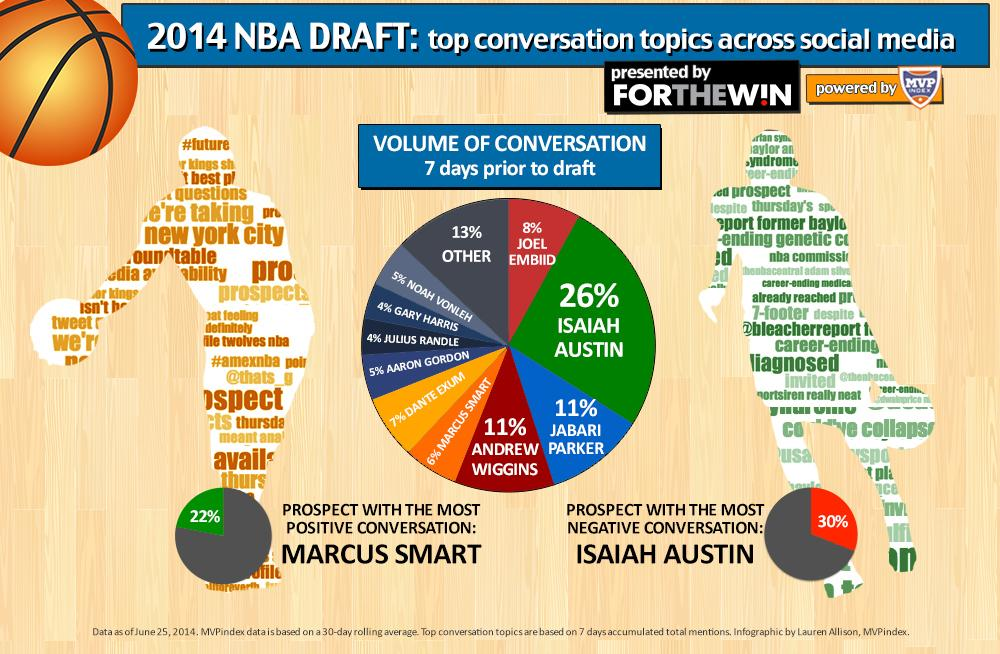Mention a couple of crucial points in this snapshot. Seven days before the draft, Isaiah Austin had the highest volume of conversation. The individuals who accounted for less than 5% of the volume of conversation were Gary Harris and Julius Randle. Who is the prospect with the most positive conversation? It is Marcus Smart. In our conversation, only 8% of the discussion centered around Joel Embiid. The person who had the most negative conversations was Isaiah Austin. 